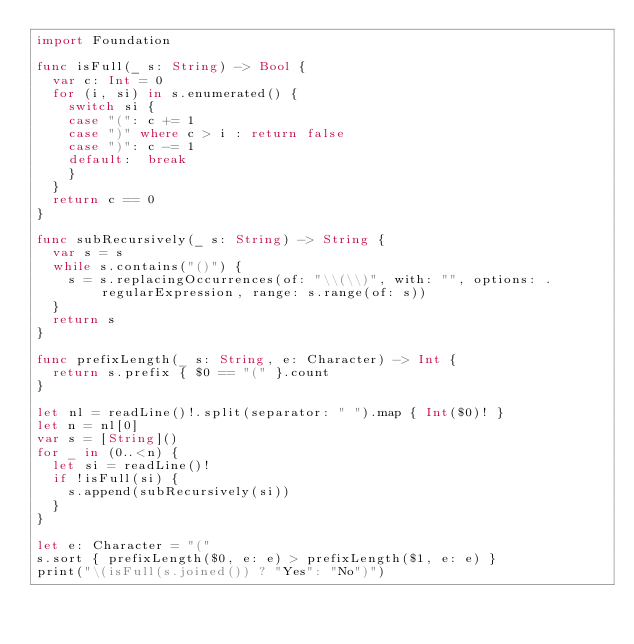<code> <loc_0><loc_0><loc_500><loc_500><_Swift_>import Foundation

func isFull(_ s: String) -> Bool {
  var c: Int = 0
  for (i, si) in s.enumerated() {
    switch si {
    case "(": c += 1
    case ")" where c > i : return false
    case ")": c -= 1
    default:  break
    }
  }
  return c == 0
}

func subRecursively(_ s: String) -> String {
  var s = s
  while s.contains("()") {
    s = s.replacingOccurrences(of: "\\(\\)", with: "", options: .regularExpression, range: s.range(of: s))
  }
  return s
}

func prefixLength(_ s: String, e: Character) -> Int {
  return s.prefix { $0 == "(" }.count
}

let nl = readLine()!.split(separator: " ").map { Int($0)! }
let n = nl[0]
var s = [String]()
for _ in (0..<n) {
  let si = readLine()!
  if !isFull(si) {
    s.append(subRecursively(si))
  }
}

let e: Character = "("
s.sort { prefixLength($0, e: e) > prefixLength($1, e: e) }
print("\(isFull(s.joined()) ? "Yes": "No")")</code> 